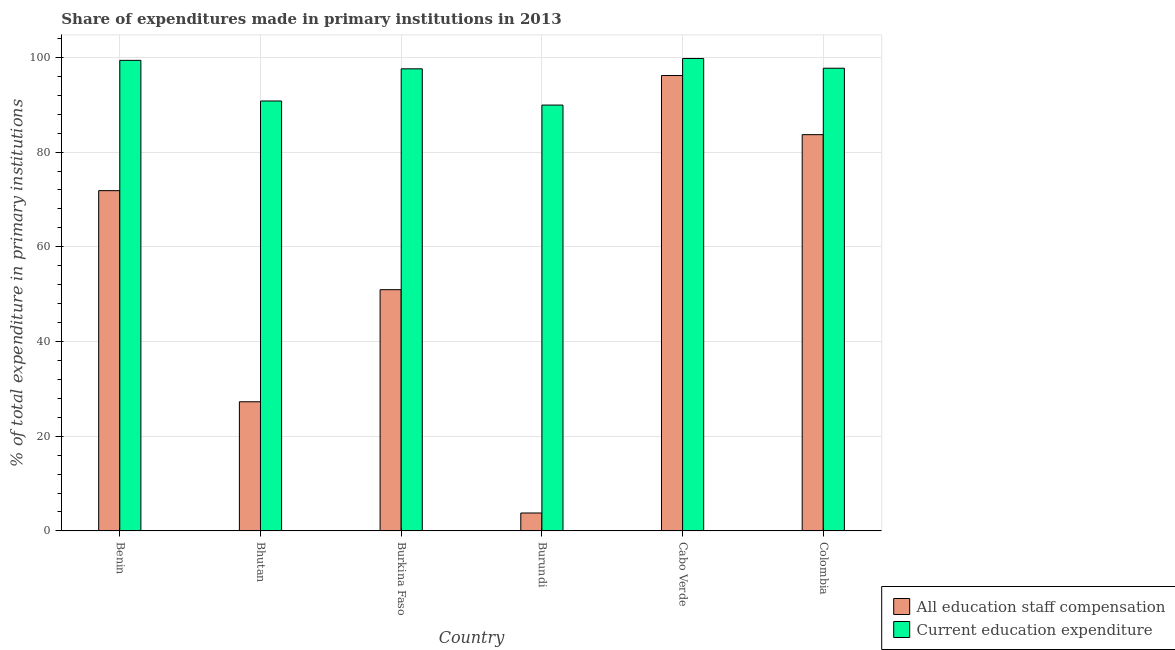How many groups of bars are there?
Give a very brief answer. 6. How many bars are there on the 5th tick from the right?
Ensure brevity in your answer.  2. What is the label of the 5th group of bars from the left?
Ensure brevity in your answer.  Cabo Verde. What is the expenditure in education in Colombia?
Provide a short and direct response. 97.7. Across all countries, what is the maximum expenditure in staff compensation?
Provide a succinct answer. 96.16. Across all countries, what is the minimum expenditure in staff compensation?
Your answer should be compact. 3.79. In which country was the expenditure in education maximum?
Your answer should be compact. Cabo Verde. In which country was the expenditure in staff compensation minimum?
Offer a very short reply. Burundi. What is the total expenditure in staff compensation in the graph?
Provide a short and direct response. 333.7. What is the difference between the expenditure in education in Benin and that in Colombia?
Your answer should be very brief. 1.66. What is the difference between the expenditure in staff compensation in Burkina Faso and the expenditure in education in Colombia?
Give a very brief answer. -46.76. What is the average expenditure in education per country?
Keep it short and to the point. 95.85. What is the difference between the expenditure in staff compensation and expenditure in education in Burkina Faso?
Provide a short and direct response. -46.64. In how many countries, is the expenditure in education greater than 52 %?
Ensure brevity in your answer.  6. What is the ratio of the expenditure in education in Bhutan to that in Colombia?
Provide a short and direct response. 0.93. Is the expenditure in staff compensation in Bhutan less than that in Burkina Faso?
Provide a succinct answer. Yes. What is the difference between the highest and the second highest expenditure in staff compensation?
Offer a terse response. 12.48. What is the difference between the highest and the lowest expenditure in staff compensation?
Give a very brief answer. 92.37. In how many countries, is the expenditure in education greater than the average expenditure in education taken over all countries?
Your answer should be compact. 4. What does the 2nd bar from the left in Burundi represents?
Offer a terse response. Current education expenditure. What does the 1st bar from the right in Burkina Faso represents?
Ensure brevity in your answer.  Current education expenditure. What is the difference between two consecutive major ticks on the Y-axis?
Ensure brevity in your answer.  20. Are the values on the major ticks of Y-axis written in scientific E-notation?
Your answer should be compact. No. How many legend labels are there?
Offer a terse response. 2. What is the title of the graph?
Make the answer very short. Share of expenditures made in primary institutions in 2013. What is the label or title of the X-axis?
Give a very brief answer. Country. What is the label or title of the Y-axis?
Offer a terse response. % of total expenditure in primary institutions. What is the % of total expenditure in primary institutions of All education staff compensation in Benin?
Keep it short and to the point. 71.85. What is the % of total expenditure in primary institutions in Current education expenditure in Benin?
Your answer should be compact. 99.37. What is the % of total expenditure in primary institutions of All education staff compensation in Bhutan?
Ensure brevity in your answer.  27.28. What is the % of total expenditure in primary institutions of Current education expenditure in Bhutan?
Ensure brevity in your answer.  90.78. What is the % of total expenditure in primary institutions of All education staff compensation in Burkina Faso?
Give a very brief answer. 50.94. What is the % of total expenditure in primary institutions in Current education expenditure in Burkina Faso?
Provide a short and direct response. 97.58. What is the % of total expenditure in primary institutions of All education staff compensation in Burundi?
Your answer should be compact. 3.79. What is the % of total expenditure in primary institutions in Current education expenditure in Burundi?
Keep it short and to the point. 89.92. What is the % of total expenditure in primary institutions in All education staff compensation in Cabo Verde?
Provide a short and direct response. 96.16. What is the % of total expenditure in primary institutions of Current education expenditure in Cabo Verde?
Your response must be concise. 99.76. What is the % of total expenditure in primary institutions in All education staff compensation in Colombia?
Provide a succinct answer. 83.68. What is the % of total expenditure in primary institutions of Current education expenditure in Colombia?
Offer a terse response. 97.7. Across all countries, what is the maximum % of total expenditure in primary institutions in All education staff compensation?
Offer a terse response. 96.16. Across all countries, what is the maximum % of total expenditure in primary institutions in Current education expenditure?
Make the answer very short. 99.76. Across all countries, what is the minimum % of total expenditure in primary institutions of All education staff compensation?
Your answer should be compact. 3.79. Across all countries, what is the minimum % of total expenditure in primary institutions of Current education expenditure?
Give a very brief answer. 89.92. What is the total % of total expenditure in primary institutions in All education staff compensation in the graph?
Give a very brief answer. 333.7. What is the total % of total expenditure in primary institutions of Current education expenditure in the graph?
Your answer should be compact. 575.11. What is the difference between the % of total expenditure in primary institutions of All education staff compensation in Benin and that in Bhutan?
Give a very brief answer. 44.57. What is the difference between the % of total expenditure in primary institutions of Current education expenditure in Benin and that in Bhutan?
Your response must be concise. 8.58. What is the difference between the % of total expenditure in primary institutions in All education staff compensation in Benin and that in Burkina Faso?
Ensure brevity in your answer.  20.91. What is the difference between the % of total expenditure in primary institutions of Current education expenditure in Benin and that in Burkina Faso?
Your answer should be very brief. 1.79. What is the difference between the % of total expenditure in primary institutions in All education staff compensation in Benin and that in Burundi?
Provide a short and direct response. 68.06. What is the difference between the % of total expenditure in primary institutions in Current education expenditure in Benin and that in Burundi?
Offer a terse response. 9.44. What is the difference between the % of total expenditure in primary institutions of All education staff compensation in Benin and that in Cabo Verde?
Make the answer very short. -24.31. What is the difference between the % of total expenditure in primary institutions in Current education expenditure in Benin and that in Cabo Verde?
Your answer should be compact. -0.39. What is the difference between the % of total expenditure in primary institutions in All education staff compensation in Benin and that in Colombia?
Keep it short and to the point. -11.83. What is the difference between the % of total expenditure in primary institutions of Current education expenditure in Benin and that in Colombia?
Make the answer very short. 1.66. What is the difference between the % of total expenditure in primary institutions of All education staff compensation in Bhutan and that in Burkina Faso?
Offer a very short reply. -23.66. What is the difference between the % of total expenditure in primary institutions in Current education expenditure in Bhutan and that in Burkina Faso?
Ensure brevity in your answer.  -6.79. What is the difference between the % of total expenditure in primary institutions in All education staff compensation in Bhutan and that in Burundi?
Keep it short and to the point. 23.49. What is the difference between the % of total expenditure in primary institutions of Current education expenditure in Bhutan and that in Burundi?
Offer a very short reply. 0.86. What is the difference between the % of total expenditure in primary institutions in All education staff compensation in Bhutan and that in Cabo Verde?
Keep it short and to the point. -68.88. What is the difference between the % of total expenditure in primary institutions of Current education expenditure in Bhutan and that in Cabo Verde?
Your response must be concise. -8.97. What is the difference between the % of total expenditure in primary institutions of All education staff compensation in Bhutan and that in Colombia?
Keep it short and to the point. -56.4. What is the difference between the % of total expenditure in primary institutions in Current education expenditure in Bhutan and that in Colombia?
Provide a short and direct response. -6.92. What is the difference between the % of total expenditure in primary institutions of All education staff compensation in Burkina Faso and that in Burundi?
Give a very brief answer. 47.15. What is the difference between the % of total expenditure in primary institutions of Current education expenditure in Burkina Faso and that in Burundi?
Offer a very short reply. 7.65. What is the difference between the % of total expenditure in primary institutions of All education staff compensation in Burkina Faso and that in Cabo Verde?
Your answer should be very brief. -45.22. What is the difference between the % of total expenditure in primary institutions in Current education expenditure in Burkina Faso and that in Cabo Verde?
Make the answer very short. -2.18. What is the difference between the % of total expenditure in primary institutions in All education staff compensation in Burkina Faso and that in Colombia?
Make the answer very short. -32.74. What is the difference between the % of total expenditure in primary institutions in Current education expenditure in Burkina Faso and that in Colombia?
Give a very brief answer. -0.13. What is the difference between the % of total expenditure in primary institutions in All education staff compensation in Burundi and that in Cabo Verde?
Give a very brief answer. -92.37. What is the difference between the % of total expenditure in primary institutions of Current education expenditure in Burundi and that in Cabo Verde?
Offer a terse response. -9.83. What is the difference between the % of total expenditure in primary institutions in All education staff compensation in Burundi and that in Colombia?
Keep it short and to the point. -79.89. What is the difference between the % of total expenditure in primary institutions of Current education expenditure in Burundi and that in Colombia?
Offer a very short reply. -7.78. What is the difference between the % of total expenditure in primary institutions of All education staff compensation in Cabo Verde and that in Colombia?
Your answer should be compact. 12.48. What is the difference between the % of total expenditure in primary institutions of Current education expenditure in Cabo Verde and that in Colombia?
Your response must be concise. 2.05. What is the difference between the % of total expenditure in primary institutions of All education staff compensation in Benin and the % of total expenditure in primary institutions of Current education expenditure in Bhutan?
Your response must be concise. -18.93. What is the difference between the % of total expenditure in primary institutions of All education staff compensation in Benin and the % of total expenditure in primary institutions of Current education expenditure in Burkina Faso?
Provide a short and direct response. -25.73. What is the difference between the % of total expenditure in primary institutions in All education staff compensation in Benin and the % of total expenditure in primary institutions in Current education expenditure in Burundi?
Offer a very short reply. -18.07. What is the difference between the % of total expenditure in primary institutions in All education staff compensation in Benin and the % of total expenditure in primary institutions in Current education expenditure in Cabo Verde?
Provide a short and direct response. -27.9. What is the difference between the % of total expenditure in primary institutions in All education staff compensation in Benin and the % of total expenditure in primary institutions in Current education expenditure in Colombia?
Offer a terse response. -25.85. What is the difference between the % of total expenditure in primary institutions in All education staff compensation in Bhutan and the % of total expenditure in primary institutions in Current education expenditure in Burkina Faso?
Your answer should be very brief. -70.3. What is the difference between the % of total expenditure in primary institutions of All education staff compensation in Bhutan and the % of total expenditure in primary institutions of Current education expenditure in Burundi?
Offer a terse response. -62.65. What is the difference between the % of total expenditure in primary institutions in All education staff compensation in Bhutan and the % of total expenditure in primary institutions in Current education expenditure in Cabo Verde?
Make the answer very short. -72.48. What is the difference between the % of total expenditure in primary institutions in All education staff compensation in Bhutan and the % of total expenditure in primary institutions in Current education expenditure in Colombia?
Make the answer very short. -70.42. What is the difference between the % of total expenditure in primary institutions of All education staff compensation in Burkina Faso and the % of total expenditure in primary institutions of Current education expenditure in Burundi?
Make the answer very short. -38.98. What is the difference between the % of total expenditure in primary institutions in All education staff compensation in Burkina Faso and the % of total expenditure in primary institutions in Current education expenditure in Cabo Verde?
Provide a succinct answer. -48.82. What is the difference between the % of total expenditure in primary institutions of All education staff compensation in Burkina Faso and the % of total expenditure in primary institutions of Current education expenditure in Colombia?
Keep it short and to the point. -46.76. What is the difference between the % of total expenditure in primary institutions in All education staff compensation in Burundi and the % of total expenditure in primary institutions in Current education expenditure in Cabo Verde?
Keep it short and to the point. -95.97. What is the difference between the % of total expenditure in primary institutions of All education staff compensation in Burundi and the % of total expenditure in primary institutions of Current education expenditure in Colombia?
Provide a short and direct response. -93.91. What is the difference between the % of total expenditure in primary institutions of All education staff compensation in Cabo Verde and the % of total expenditure in primary institutions of Current education expenditure in Colombia?
Your answer should be compact. -1.54. What is the average % of total expenditure in primary institutions of All education staff compensation per country?
Ensure brevity in your answer.  55.62. What is the average % of total expenditure in primary institutions of Current education expenditure per country?
Your answer should be compact. 95.85. What is the difference between the % of total expenditure in primary institutions of All education staff compensation and % of total expenditure in primary institutions of Current education expenditure in Benin?
Keep it short and to the point. -27.51. What is the difference between the % of total expenditure in primary institutions in All education staff compensation and % of total expenditure in primary institutions in Current education expenditure in Bhutan?
Keep it short and to the point. -63.51. What is the difference between the % of total expenditure in primary institutions in All education staff compensation and % of total expenditure in primary institutions in Current education expenditure in Burkina Faso?
Give a very brief answer. -46.64. What is the difference between the % of total expenditure in primary institutions in All education staff compensation and % of total expenditure in primary institutions in Current education expenditure in Burundi?
Give a very brief answer. -86.13. What is the difference between the % of total expenditure in primary institutions of All education staff compensation and % of total expenditure in primary institutions of Current education expenditure in Cabo Verde?
Make the answer very short. -3.59. What is the difference between the % of total expenditure in primary institutions in All education staff compensation and % of total expenditure in primary institutions in Current education expenditure in Colombia?
Your answer should be very brief. -14.02. What is the ratio of the % of total expenditure in primary institutions of All education staff compensation in Benin to that in Bhutan?
Offer a terse response. 2.63. What is the ratio of the % of total expenditure in primary institutions of Current education expenditure in Benin to that in Bhutan?
Your answer should be compact. 1.09. What is the ratio of the % of total expenditure in primary institutions in All education staff compensation in Benin to that in Burkina Faso?
Your answer should be compact. 1.41. What is the ratio of the % of total expenditure in primary institutions of Current education expenditure in Benin to that in Burkina Faso?
Give a very brief answer. 1.02. What is the ratio of the % of total expenditure in primary institutions in All education staff compensation in Benin to that in Burundi?
Provide a succinct answer. 18.96. What is the ratio of the % of total expenditure in primary institutions in Current education expenditure in Benin to that in Burundi?
Your answer should be very brief. 1.1. What is the ratio of the % of total expenditure in primary institutions of All education staff compensation in Benin to that in Cabo Verde?
Your answer should be very brief. 0.75. What is the ratio of the % of total expenditure in primary institutions in All education staff compensation in Benin to that in Colombia?
Provide a succinct answer. 0.86. What is the ratio of the % of total expenditure in primary institutions in Current education expenditure in Benin to that in Colombia?
Your answer should be very brief. 1.02. What is the ratio of the % of total expenditure in primary institutions of All education staff compensation in Bhutan to that in Burkina Faso?
Provide a short and direct response. 0.54. What is the ratio of the % of total expenditure in primary institutions of Current education expenditure in Bhutan to that in Burkina Faso?
Your response must be concise. 0.93. What is the ratio of the % of total expenditure in primary institutions of All education staff compensation in Bhutan to that in Burundi?
Your response must be concise. 7.2. What is the ratio of the % of total expenditure in primary institutions in Current education expenditure in Bhutan to that in Burundi?
Offer a very short reply. 1.01. What is the ratio of the % of total expenditure in primary institutions in All education staff compensation in Bhutan to that in Cabo Verde?
Give a very brief answer. 0.28. What is the ratio of the % of total expenditure in primary institutions in Current education expenditure in Bhutan to that in Cabo Verde?
Make the answer very short. 0.91. What is the ratio of the % of total expenditure in primary institutions in All education staff compensation in Bhutan to that in Colombia?
Your answer should be compact. 0.33. What is the ratio of the % of total expenditure in primary institutions in Current education expenditure in Bhutan to that in Colombia?
Provide a succinct answer. 0.93. What is the ratio of the % of total expenditure in primary institutions of All education staff compensation in Burkina Faso to that in Burundi?
Your response must be concise. 13.44. What is the ratio of the % of total expenditure in primary institutions in Current education expenditure in Burkina Faso to that in Burundi?
Provide a succinct answer. 1.09. What is the ratio of the % of total expenditure in primary institutions of All education staff compensation in Burkina Faso to that in Cabo Verde?
Offer a very short reply. 0.53. What is the ratio of the % of total expenditure in primary institutions of Current education expenditure in Burkina Faso to that in Cabo Verde?
Make the answer very short. 0.98. What is the ratio of the % of total expenditure in primary institutions of All education staff compensation in Burkina Faso to that in Colombia?
Give a very brief answer. 0.61. What is the ratio of the % of total expenditure in primary institutions in Current education expenditure in Burkina Faso to that in Colombia?
Make the answer very short. 1. What is the ratio of the % of total expenditure in primary institutions in All education staff compensation in Burundi to that in Cabo Verde?
Keep it short and to the point. 0.04. What is the ratio of the % of total expenditure in primary institutions in Current education expenditure in Burundi to that in Cabo Verde?
Give a very brief answer. 0.9. What is the ratio of the % of total expenditure in primary institutions of All education staff compensation in Burundi to that in Colombia?
Make the answer very short. 0.05. What is the ratio of the % of total expenditure in primary institutions in Current education expenditure in Burundi to that in Colombia?
Ensure brevity in your answer.  0.92. What is the ratio of the % of total expenditure in primary institutions of All education staff compensation in Cabo Verde to that in Colombia?
Offer a terse response. 1.15. What is the difference between the highest and the second highest % of total expenditure in primary institutions in All education staff compensation?
Provide a succinct answer. 12.48. What is the difference between the highest and the second highest % of total expenditure in primary institutions in Current education expenditure?
Ensure brevity in your answer.  0.39. What is the difference between the highest and the lowest % of total expenditure in primary institutions of All education staff compensation?
Your response must be concise. 92.37. What is the difference between the highest and the lowest % of total expenditure in primary institutions of Current education expenditure?
Provide a short and direct response. 9.83. 